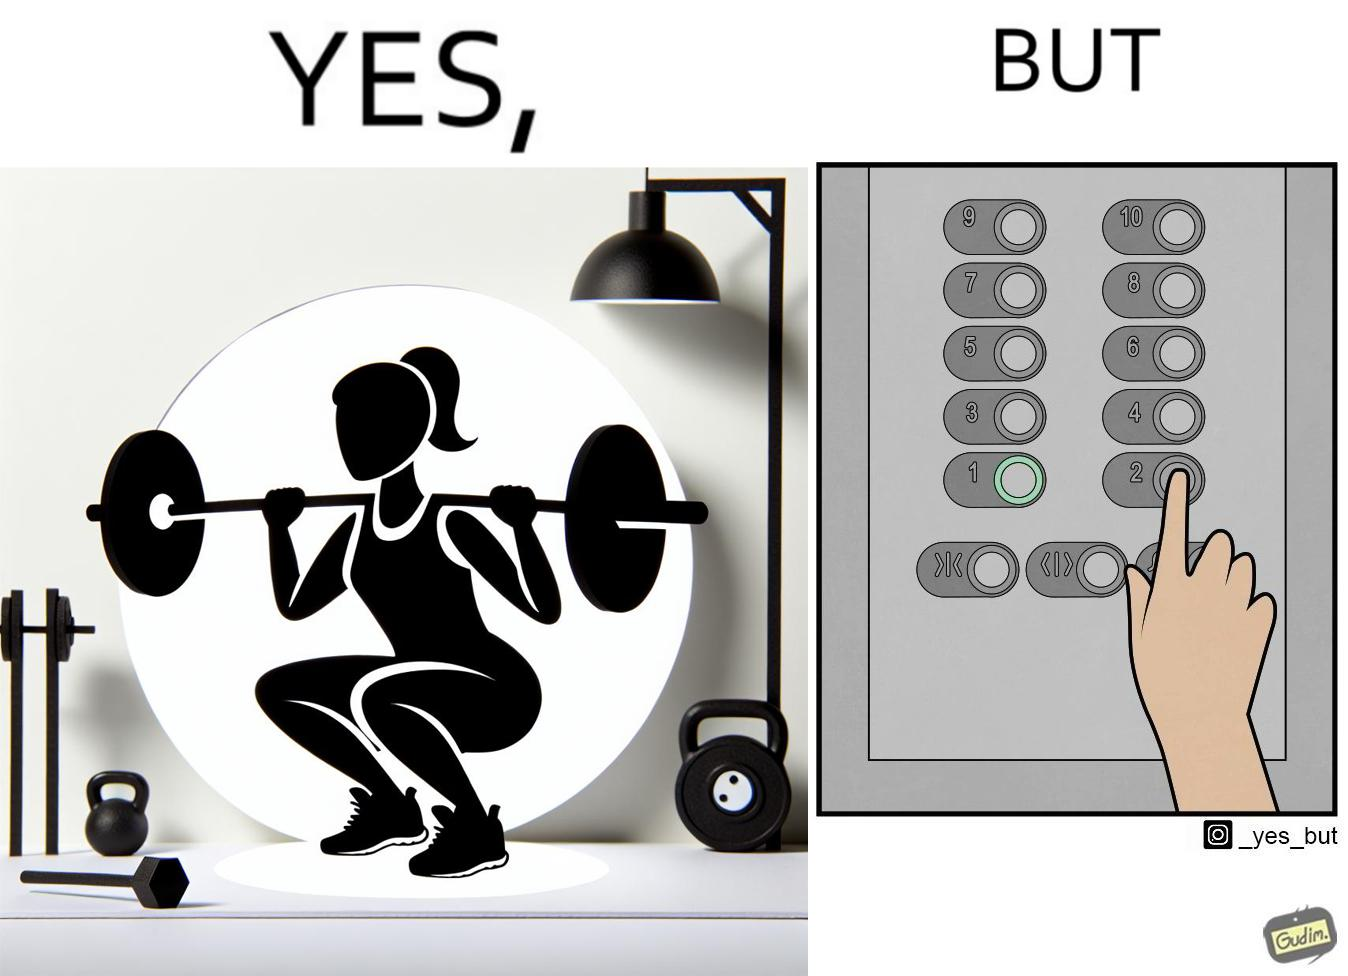Is there satirical content in this image? Yes, this image is satirical. 